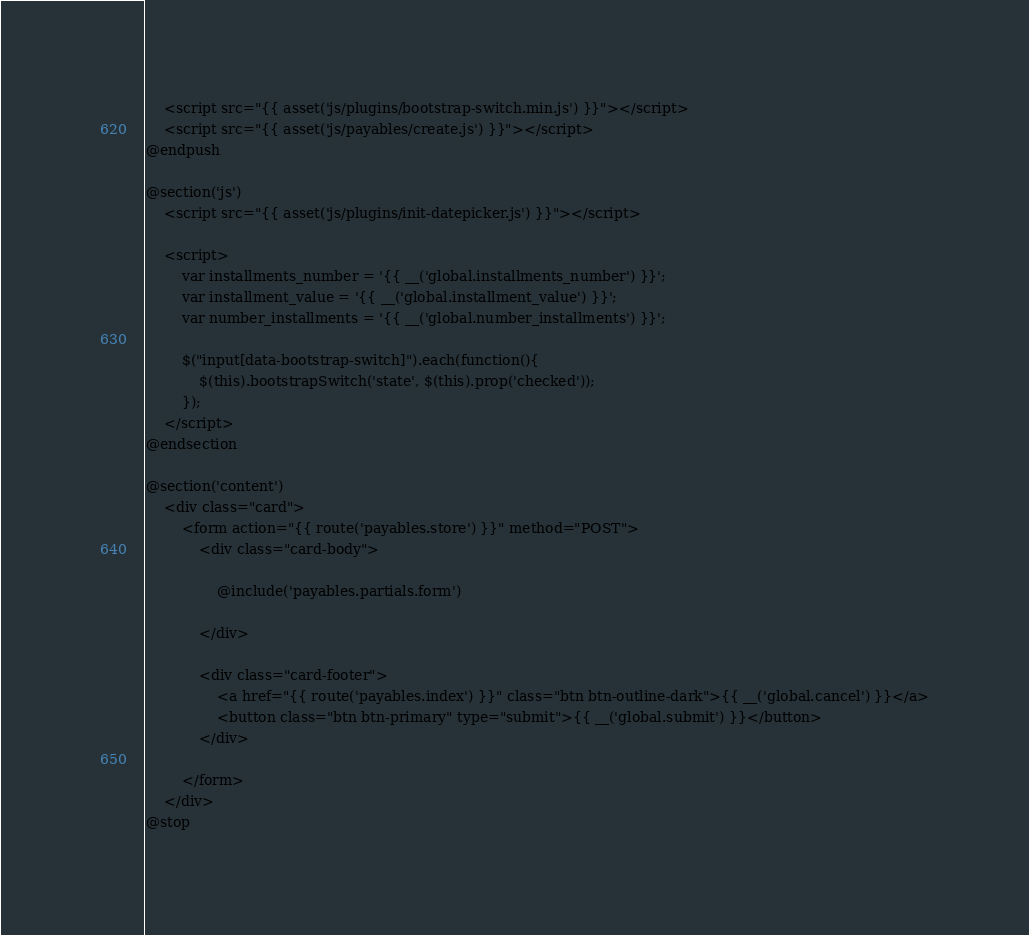<code> <loc_0><loc_0><loc_500><loc_500><_PHP_>    <script src="{{ asset('js/plugins/bootstrap-switch.min.js') }}"></script>
    <script src="{{ asset('js/payables/create.js') }}"></script>
@endpush

@section('js')
    <script src="{{ asset('js/plugins/init-datepicker.js') }}"></script>

    <script>
        var installments_number = '{{ __('global.installments_number') }}';
        var installment_value = '{{ __('global.installment_value') }}';
        var number_installments = '{{ __('global.number_installments') }}';
        
        $("input[data-bootstrap-switch]").each(function(){
            $(this).bootstrapSwitch('state', $(this).prop('checked'));
        });
    </script>
@endsection

@section('content')
    <div class="card">
        <form action="{{ route('payables.store') }}" method="POST">
            <div class="card-body">

                @include('payables.partials.form')

            </div>

            <div class="card-footer">
                <a href="{{ route('payables.index') }}" class="btn btn-outline-dark">{{ __('global.cancel') }}</a>
                <button class="btn btn-primary" type="submit">{{ __('global.submit') }}</button>
            </div>
            
        </form>
    </div>
@stop
</code> 